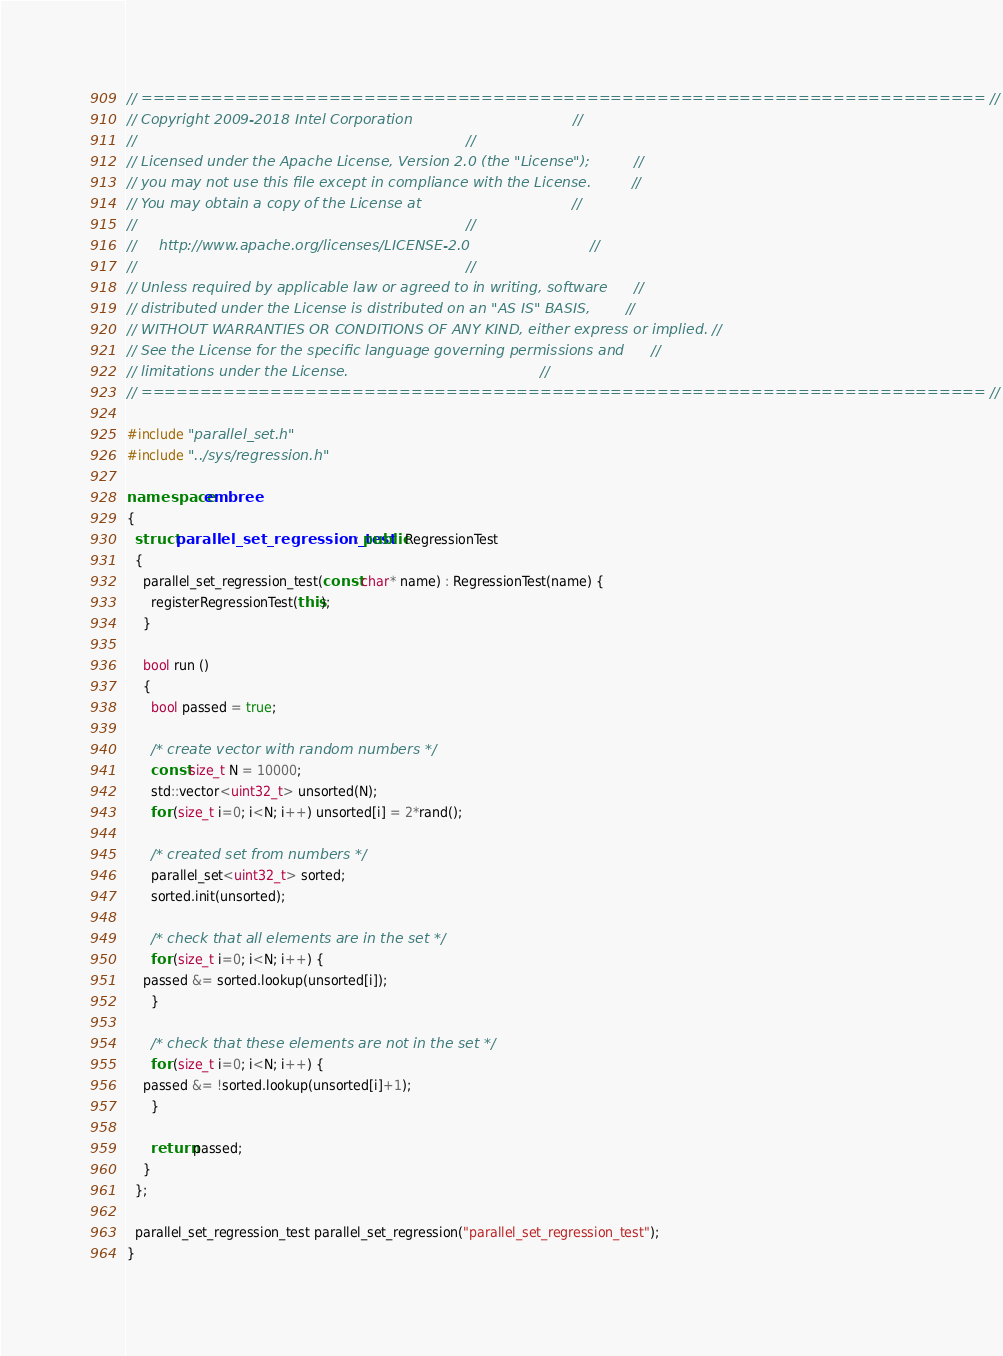<code> <loc_0><loc_0><loc_500><loc_500><_C++_>// ======================================================================== //
// Copyright 2009-2018 Intel Corporation                                    //
//                                                                          //
// Licensed under the Apache License, Version 2.0 (the "License");          //
// you may not use this file except in compliance with the License.         //
// You may obtain a copy of the License at                                  //
//                                                                          //
//     http://www.apache.org/licenses/LICENSE-2.0                           //
//                                                                          //
// Unless required by applicable law or agreed to in writing, software      //
// distributed under the License is distributed on an "AS IS" BASIS,        //
// WITHOUT WARRANTIES OR CONDITIONS OF ANY KIND, either express or implied. //
// See the License for the specific language governing permissions and      //
// limitations under the License.                                           //
// ======================================================================== //

#include "parallel_set.h"
#include "../sys/regression.h"

namespace embree
{
  struct parallel_set_regression_test : public RegressionTest
  {
    parallel_set_regression_test(const char* name) : RegressionTest(name) {
      registerRegressionTest(this);
    }
    
    bool run ()
    {
      bool passed = true;

      /* create vector with random numbers */
      const size_t N = 10000;
      std::vector<uint32_t> unsorted(N);
      for (size_t i=0; i<N; i++) unsorted[i] = 2*rand();
      
      /* created set from numbers */
      parallel_set<uint32_t> sorted;
      sorted.init(unsorted);

      /* check that all elements are in the set */
      for (size_t i=0; i<N; i++) {
	passed &= sorted.lookup(unsorted[i]);
      }

      /* check that these elements are not in the set */
      for (size_t i=0; i<N; i++) {
	passed &= !sorted.lookup(unsorted[i]+1);
      }

      return passed;
    }
  };

  parallel_set_regression_test parallel_set_regression("parallel_set_regression_test");
}
</code> 